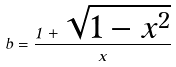Convert formula to latex. <formula><loc_0><loc_0><loc_500><loc_500>b = \frac { 1 + \sqrt { 1 - x ^ { 2 } } } { x }</formula> 